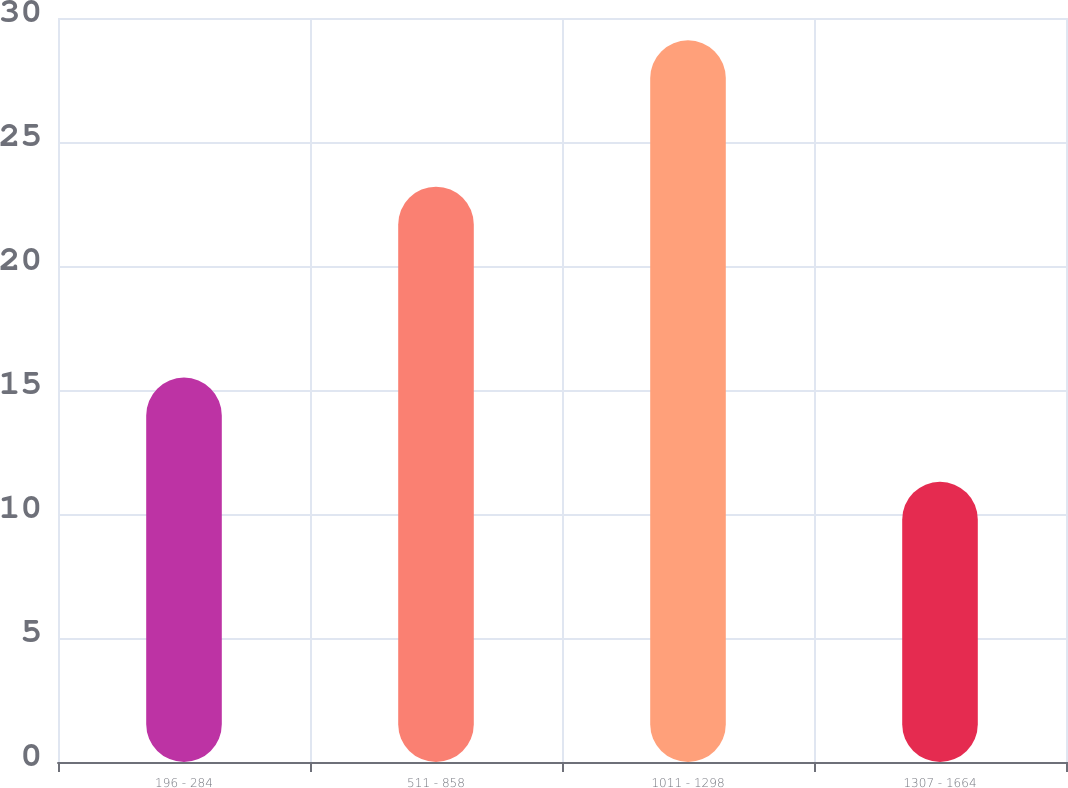Convert chart. <chart><loc_0><loc_0><loc_500><loc_500><bar_chart><fcel>196 - 284<fcel>511 - 858<fcel>1011 - 1298<fcel>1307 - 1664<nl><fcel>15.5<fcel>23.2<fcel>29.1<fcel>11.3<nl></chart> 